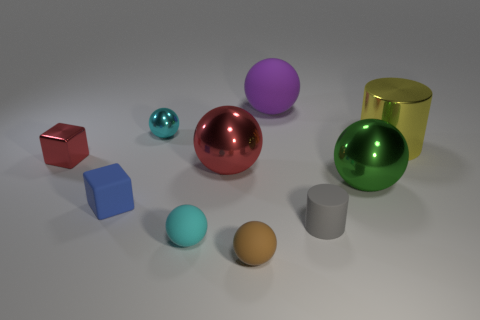How many objects are there in the image, and can you describe their shapes and colors? There are nine objects in the image, each with a distinct shape and color. Starting from the left: a small red cube, a tiny cyan sphere, a small blue cube, a medium-sized metallic red sphere, a green metallic sphere, a large purple sphere, a yellow metallic cylinder, a brown egg-shaped object, and a silver cylindrical object. 